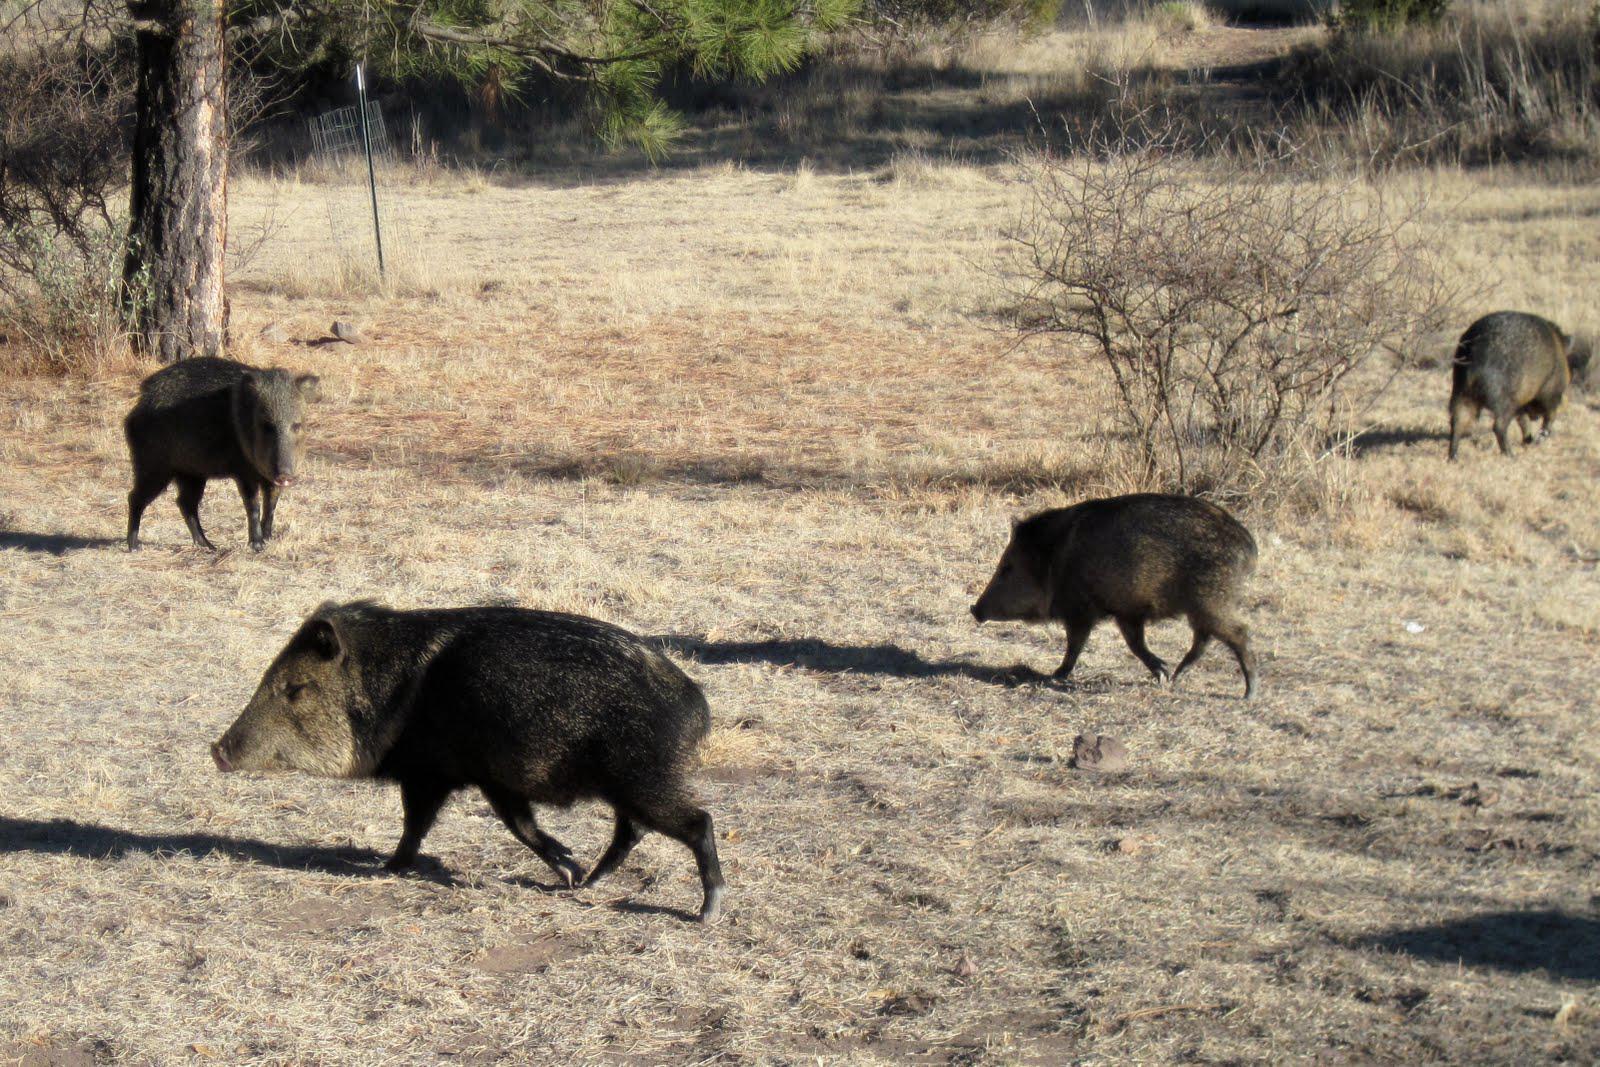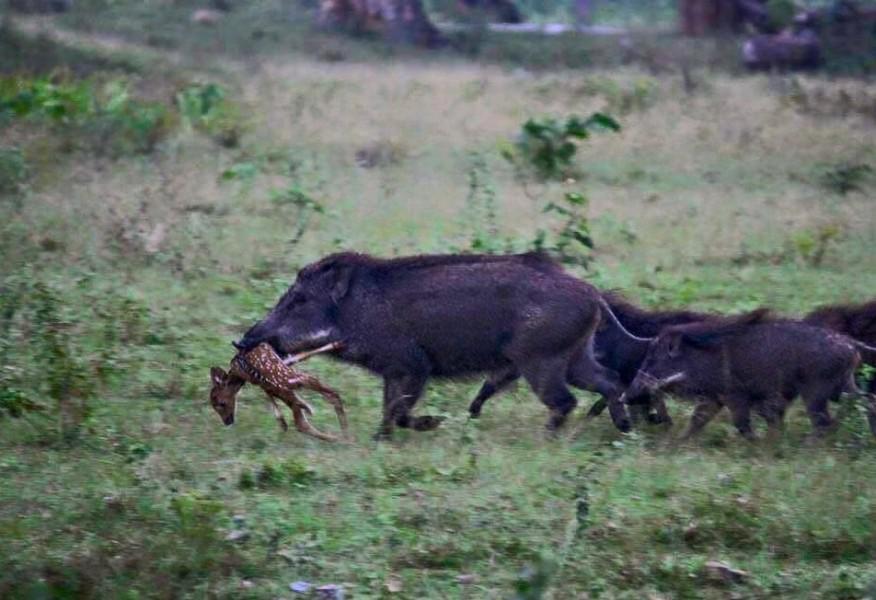The first image is the image on the left, the second image is the image on the right. Given the left and right images, does the statement "One or more boars are facing a predator in the right image." hold true? Answer yes or no. No. The first image is the image on the left, the second image is the image on the right. For the images displayed, is the sentence "Left image shows at least 8 dark hogs in a cleared area next to foliage." factually correct? Answer yes or no. No. 